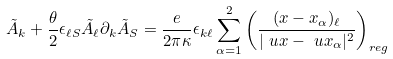<formula> <loc_0><loc_0><loc_500><loc_500>\tilde { A } _ { k } + \frac { \theta } { 2 } \epsilon _ { \ell S } \tilde { A } _ { \ell } \partial _ { k } \tilde { A } _ { S } = \frac { e } { 2 \pi \kappa } \epsilon _ { k \ell } \sum ^ { 2 } _ { \alpha = 1 } \left ( \frac { ( x - x _ { \alpha } ) _ { \ell } } { | \ u x - \ u x _ { \alpha } | ^ { 2 } } \right ) _ { r e g }</formula> 